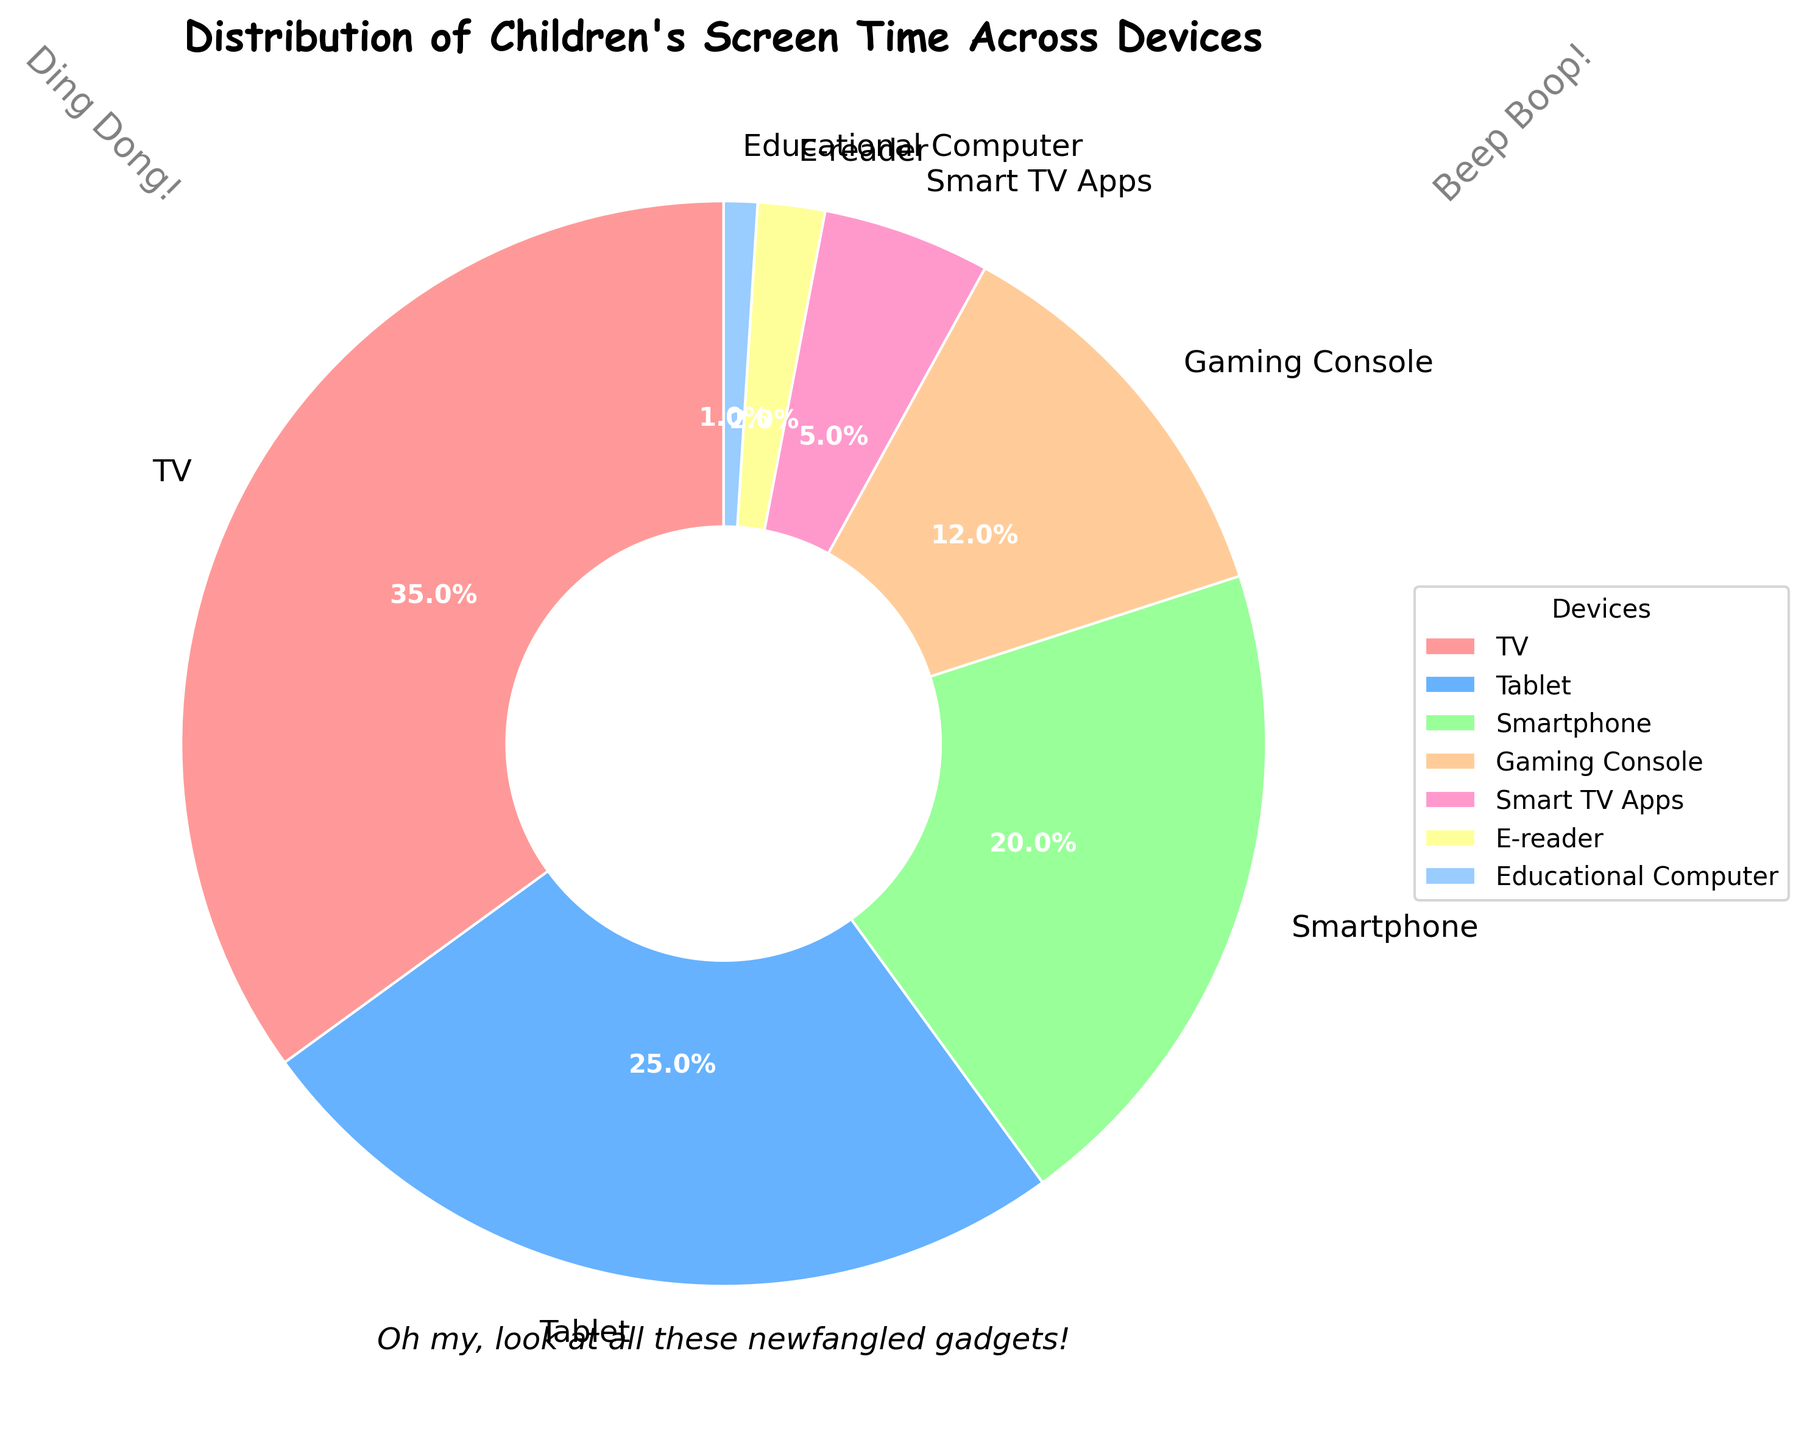What device occupies the largest portion of the children's screen time? The figure shows the percentage of screen time divided among different devices. The TV segment is noticeably the biggest one.
Answer: TV How much more screen time does the TV consume compared to the Gaming Console? The TV occupies 35% of the screen time and the Gaming Console occupies 12%. Subtract 12% from 35% to find the difference. 35 - 12 = 23.
Answer: 23% Which device ranks third in terms of children's screen time usage? The percentages listed in the pie chart are TV (35%), Tablet (25%), and Smartphone (20%). The third-largest value is for the Smartphone.
Answer: Smartphone Which device is used the least by children for screen time? The smallest segment on the pie chart is labeled with the lowest percentage, which is 1% for Educational Computer.
Answer: Educational Computer What's the combined percentage of screen time for Smart TV Apps and E-reader? Smart TV Apps and E-reader have percentages of 5% and 2%, respectively. Add 5 + 2 to find the combined percentage.
Answer: 7% If we group TV, Tablet, and Smartphone as 'Primary Devices', what percentage of screen time do they collectively account for? The percentages for TV, Tablet, and Smartphone are 35%, 25%, and 20%. Add these together to find the collective percentage: 35 + 25 + 20 = 80%.
Answer: 80% Looking at the colors of the pie chart, can you identify which device is represented by the green segment? By referring to the color-coded segments, the green segment represents the Tablet, which has 25% of the screen time.
Answer: Tablet Is the total screen time percentage for Gaming Console and Smartphone greater than the screen time percentage for TV? Gaming Console has 12% and Smartphone has 20%. Their combined percentage is 12 + 20 = 32%. TV has 35%. Since 32% is less than 35%, the total screen time for Gaming Console and Smartphone is not greater than the TV.
Answer: No Which segment appears to have the second smallest size? The pie chart shows that the second smallest segment, next to Educational Computer (1%), is for E-reader, which has 2%.
Answer: E-reader If you were to add up the percentages for all devices excluding TV, what would the total percentage be? Excluding TV, the remaining devices are Tablet (25%), Smartphone (20%), Gaming Console (12%), Smart TV Apps (5%), E-reader (2%), and Educational Computer (1%). Summing these values gives 25 + 20 + 12 + 5 + 2 + 1 = 65%.
Answer: 65% 